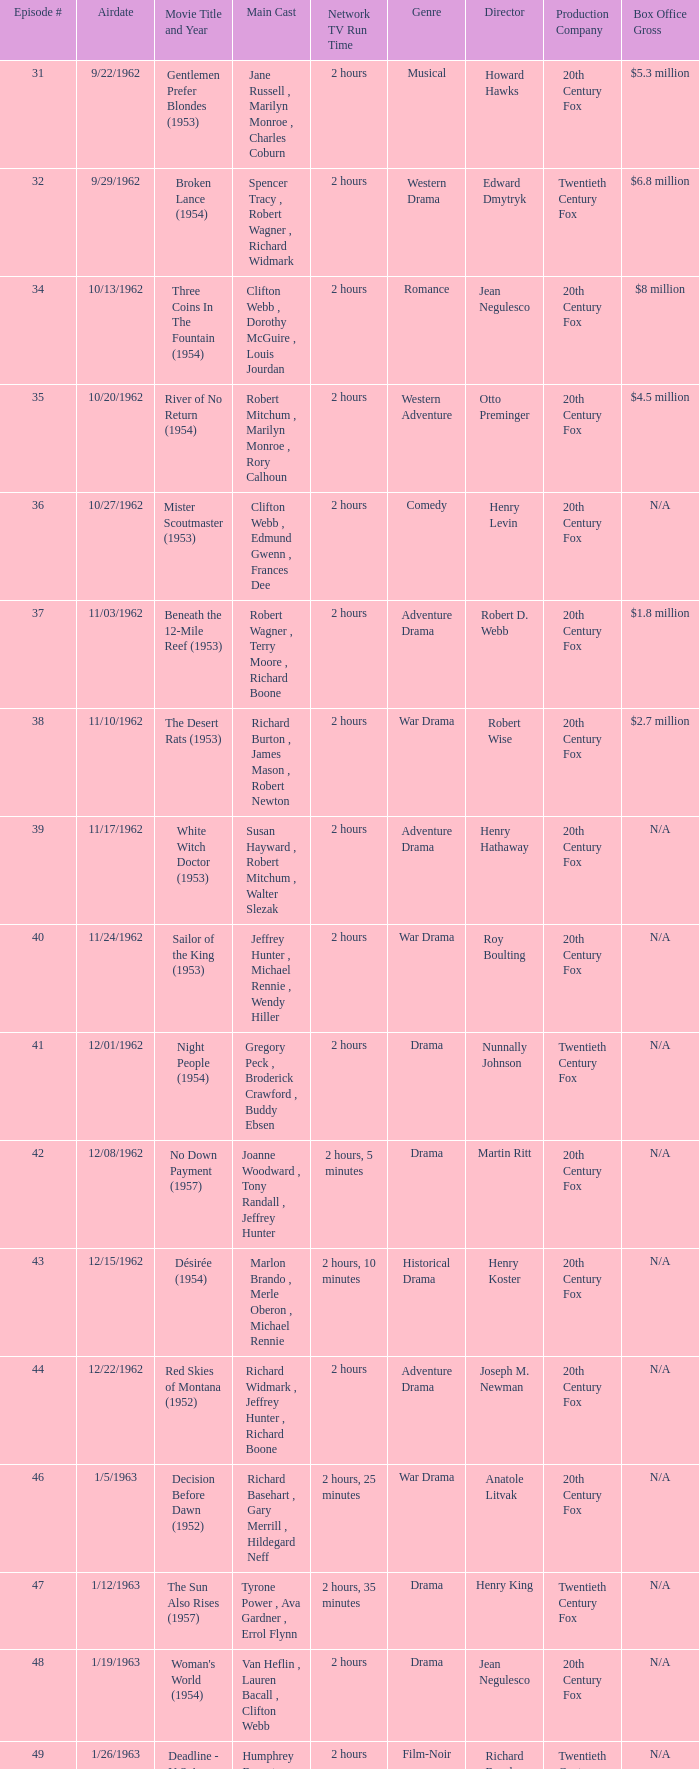What movie did dana wynter , mel ferrer , theodore bikel star in? Fraulein (1958). 